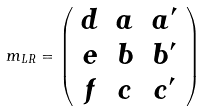<formula> <loc_0><loc_0><loc_500><loc_500>m _ { L R } = \left ( \begin{array} { c c c } d & a & a ^ { \prime } \\ e & b & b ^ { \prime } \\ f & c & c ^ { \prime } \end{array} \right )</formula> 